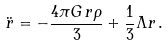Convert formula to latex. <formula><loc_0><loc_0><loc_500><loc_500>\ddot { r } = - \frac { 4 \pi G \, r \rho } { 3 } + \frac { 1 } { 3 } \Lambda r \, .</formula> 